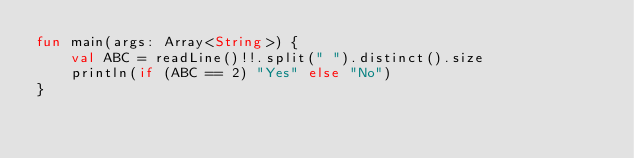Convert code to text. <code><loc_0><loc_0><loc_500><loc_500><_Kotlin_>fun main(args: Array<String>) {
    val ABC = readLine()!!.split(" ").distinct().size
    println(if (ABC == 2) "Yes" else "No")
}</code> 